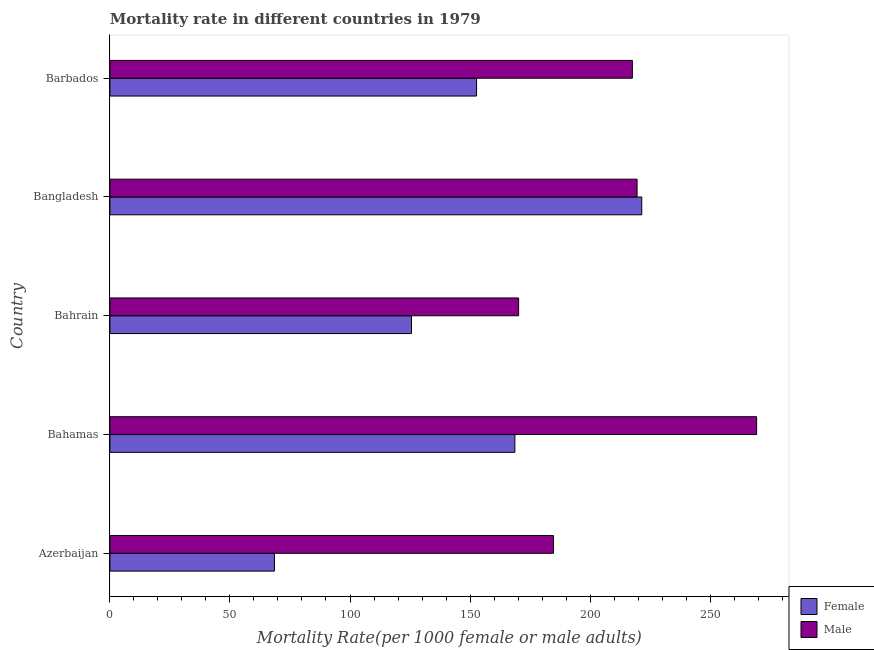How many different coloured bars are there?
Your answer should be very brief. 2. Are the number of bars per tick equal to the number of legend labels?
Offer a terse response. Yes. What is the label of the 5th group of bars from the top?
Your answer should be very brief. Azerbaijan. In how many cases, is the number of bars for a given country not equal to the number of legend labels?
Make the answer very short. 0. What is the female mortality rate in Barbados?
Your response must be concise. 152.72. Across all countries, what is the maximum female mortality rate?
Your answer should be compact. 221.51. Across all countries, what is the minimum female mortality rate?
Make the answer very short. 68.53. In which country was the male mortality rate maximum?
Provide a short and direct response. Bahamas. In which country was the female mortality rate minimum?
Provide a succinct answer. Azerbaijan. What is the total male mortality rate in the graph?
Provide a short and direct response. 1061.5. What is the difference between the female mortality rate in Azerbaijan and that in Bahamas?
Offer a very short reply. -100.13. What is the difference between the female mortality rate in Bangladesh and the male mortality rate in Azerbaijan?
Your response must be concise. 36.78. What is the average male mortality rate per country?
Your answer should be very brief. 212.3. What is the difference between the male mortality rate and female mortality rate in Barbados?
Offer a terse response. 64.89. What is the ratio of the male mortality rate in Bahamas to that in Bahrain?
Offer a terse response. 1.58. Is the male mortality rate in Bangladesh less than that in Barbados?
Your answer should be compact. No. What is the difference between the highest and the second highest female mortality rate?
Give a very brief answer. 52.84. What is the difference between the highest and the lowest male mortality rate?
Keep it short and to the point. 99.13. In how many countries, is the male mortality rate greater than the average male mortality rate taken over all countries?
Your response must be concise. 3. Is the sum of the male mortality rate in Bahamas and Bangladesh greater than the maximum female mortality rate across all countries?
Your answer should be very brief. Yes. How many bars are there?
Your answer should be compact. 10. Are all the bars in the graph horizontal?
Keep it short and to the point. Yes. Does the graph contain grids?
Offer a very short reply. No. How many legend labels are there?
Offer a very short reply. 2. How are the legend labels stacked?
Offer a very short reply. Vertical. What is the title of the graph?
Offer a terse response. Mortality rate in different countries in 1979. Does "Measles" appear as one of the legend labels in the graph?
Offer a terse response. No. What is the label or title of the X-axis?
Your answer should be compact. Mortality Rate(per 1000 female or male adults). What is the Mortality Rate(per 1000 female or male adults) in Female in Azerbaijan?
Your answer should be very brief. 68.53. What is the Mortality Rate(per 1000 female or male adults) of Male in Azerbaijan?
Provide a succinct answer. 184.73. What is the Mortality Rate(per 1000 female or male adults) in Female in Bahamas?
Ensure brevity in your answer.  168.67. What is the Mortality Rate(per 1000 female or male adults) of Male in Bahamas?
Offer a very short reply. 269.36. What is the Mortality Rate(per 1000 female or male adults) in Female in Bahrain?
Provide a short and direct response. 125.61. What is the Mortality Rate(per 1000 female or male adults) in Male in Bahrain?
Make the answer very short. 170.23. What is the Mortality Rate(per 1000 female or male adults) in Female in Bangladesh?
Your response must be concise. 221.51. What is the Mortality Rate(per 1000 female or male adults) of Male in Bangladesh?
Provide a short and direct response. 219.57. What is the Mortality Rate(per 1000 female or male adults) of Female in Barbados?
Offer a terse response. 152.72. What is the Mortality Rate(per 1000 female or male adults) in Male in Barbados?
Provide a short and direct response. 217.61. Across all countries, what is the maximum Mortality Rate(per 1000 female or male adults) of Female?
Ensure brevity in your answer.  221.51. Across all countries, what is the maximum Mortality Rate(per 1000 female or male adults) of Male?
Offer a terse response. 269.36. Across all countries, what is the minimum Mortality Rate(per 1000 female or male adults) of Female?
Offer a terse response. 68.53. Across all countries, what is the minimum Mortality Rate(per 1000 female or male adults) in Male?
Offer a very short reply. 170.23. What is the total Mortality Rate(per 1000 female or male adults) in Female in the graph?
Ensure brevity in your answer.  737.03. What is the total Mortality Rate(per 1000 female or male adults) of Male in the graph?
Provide a succinct answer. 1061.5. What is the difference between the Mortality Rate(per 1000 female or male adults) of Female in Azerbaijan and that in Bahamas?
Keep it short and to the point. -100.13. What is the difference between the Mortality Rate(per 1000 female or male adults) of Male in Azerbaijan and that in Bahamas?
Your response must be concise. -84.63. What is the difference between the Mortality Rate(per 1000 female or male adults) in Female in Azerbaijan and that in Bahrain?
Your response must be concise. -57.07. What is the difference between the Mortality Rate(per 1000 female or male adults) in Male in Azerbaijan and that in Bahrain?
Your answer should be very brief. 14.5. What is the difference between the Mortality Rate(per 1000 female or male adults) in Female in Azerbaijan and that in Bangladesh?
Make the answer very short. -152.98. What is the difference between the Mortality Rate(per 1000 female or male adults) of Male in Azerbaijan and that in Bangladesh?
Offer a very short reply. -34.83. What is the difference between the Mortality Rate(per 1000 female or male adults) of Female in Azerbaijan and that in Barbados?
Provide a succinct answer. -84.18. What is the difference between the Mortality Rate(per 1000 female or male adults) of Male in Azerbaijan and that in Barbados?
Provide a short and direct response. -32.88. What is the difference between the Mortality Rate(per 1000 female or male adults) in Female in Bahamas and that in Bahrain?
Your response must be concise. 43.06. What is the difference between the Mortality Rate(per 1000 female or male adults) in Male in Bahamas and that in Bahrain?
Make the answer very short. 99.13. What is the difference between the Mortality Rate(per 1000 female or male adults) in Female in Bahamas and that in Bangladesh?
Your response must be concise. -52.84. What is the difference between the Mortality Rate(per 1000 female or male adults) of Male in Bahamas and that in Bangladesh?
Ensure brevity in your answer.  49.79. What is the difference between the Mortality Rate(per 1000 female or male adults) in Female in Bahamas and that in Barbados?
Offer a terse response. 15.95. What is the difference between the Mortality Rate(per 1000 female or male adults) of Male in Bahamas and that in Barbados?
Offer a very short reply. 51.75. What is the difference between the Mortality Rate(per 1000 female or male adults) in Female in Bahrain and that in Bangladesh?
Ensure brevity in your answer.  -95.91. What is the difference between the Mortality Rate(per 1000 female or male adults) in Male in Bahrain and that in Bangladesh?
Keep it short and to the point. -49.34. What is the difference between the Mortality Rate(per 1000 female or male adults) in Female in Bahrain and that in Barbados?
Your answer should be compact. -27.11. What is the difference between the Mortality Rate(per 1000 female or male adults) of Male in Bahrain and that in Barbados?
Make the answer very short. -47.38. What is the difference between the Mortality Rate(per 1000 female or male adults) of Female in Bangladesh and that in Barbados?
Your answer should be very brief. 68.8. What is the difference between the Mortality Rate(per 1000 female or male adults) of Male in Bangladesh and that in Barbados?
Provide a short and direct response. 1.96. What is the difference between the Mortality Rate(per 1000 female or male adults) of Female in Azerbaijan and the Mortality Rate(per 1000 female or male adults) of Male in Bahamas?
Your answer should be very brief. -200.83. What is the difference between the Mortality Rate(per 1000 female or male adults) of Female in Azerbaijan and the Mortality Rate(per 1000 female or male adults) of Male in Bahrain?
Keep it short and to the point. -101.7. What is the difference between the Mortality Rate(per 1000 female or male adults) of Female in Azerbaijan and the Mortality Rate(per 1000 female or male adults) of Male in Bangladesh?
Offer a terse response. -151.03. What is the difference between the Mortality Rate(per 1000 female or male adults) in Female in Azerbaijan and the Mortality Rate(per 1000 female or male adults) in Male in Barbados?
Your answer should be compact. -149.07. What is the difference between the Mortality Rate(per 1000 female or male adults) in Female in Bahamas and the Mortality Rate(per 1000 female or male adults) in Male in Bahrain?
Your answer should be very brief. -1.56. What is the difference between the Mortality Rate(per 1000 female or male adults) in Female in Bahamas and the Mortality Rate(per 1000 female or male adults) in Male in Bangladesh?
Offer a terse response. -50.9. What is the difference between the Mortality Rate(per 1000 female or male adults) of Female in Bahamas and the Mortality Rate(per 1000 female or male adults) of Male in Barbados?
Your response must be concise. -48.94. What is the difference between the Mortality Rate(per 1000 female or male adults) in Female in Bahrain and the Mortality Rate(per 1000 female or male adults) in Male in Bangladesh?
Your response must be concise. -93.96. What is the difference between the Mortality Rate(per 1000 female or male adults) in Female in Bahrain and the Mortality Rate(per 1000 female or male adults) in Male in Barbados?
Offer a terse response. -92. What is the difference between the Mortality Rate(per 1000 female or male adults) in Female in Bangladesh and the Mortality Rate(per 1000 female or male adults) in Male in Barbados?
Keep it short and to the point. 3.9. What is the average Mortality Rate(per 1000 female or male adults) in Female per country?
Offer a very short reply. 147.41. What is the average Mortality Rate(per 1000 female or male adults) of Male per country?
Your response must be concise. 212.3. What is the difference between the Mortality Rate(per 1000 female or male adults) of Female and Mortality Rate(per 1000 female or male adults) of Male in Azerbaijan?
Ensure brevity in your answer.  -116.2. What is the difference between the Mortality Rate(per 1000 female or male adults) of Female and Mortality Rate(per 1000 female or male adults) of Male in Bahamas?
Your response must be concise. -100.69. What is the difference between the Mortality Rate(per 1000 female or male adults) in Female and Mortality Rate(per 1000 female or male adults) in Male in Bahrain?
Ensure brevity in your answer.  -44.62. What is the difference between the Mortality Rate(per 1000 female or male adults) of Female and Mortality Rate(per 1000 female or male adults) of Male in Bangladesh?
Make the answer very short. 1.95. What is the difference between the Mortality Rate(per 1000 female or male adults) of Female and Mortality Rate(per 1000 female or male adults) of Male in Barbados?
Keep it short and to the point. -64.89. What is the ratio of the Mortality Rate(per 1000 female or male adults) in Female in Azerbaijan to that in Bahamas?
Offer a terse response. 0.41. What is the ratio of the Mortality Rate(per 1000 female or male adults) of Male in Azerbaijan to that in Bahamas?
Your answer should be compact. 0.69. What is the ratio of the Mortality Rate(per 1000 female or male adults) of Female in Azerbaijan to that in Bahrain?
Offer a very short reply. 0.55. What is the ratio of the Mortality Rate(per 1000 female or male adults) in Male in Azerbaijan to that in Bahrain?
Your answer should be compact. 1.09. What is the ratio of the Mortality Rate(per 1000 female or male adults) of Female in Azerbaijan to that in Bangladesh?
Offer a terse response. 0.31. What is the ratio of the Mortality Rate(per 1000 female or male adults) in Male in Azerbaijan to that in Bangladesh?
Your answer should be compact. 0.84. What is the ratio of the Mortality Rate(per 1000 female or male adults) in Female in Azerbaijan to that in Barbados?
Offer a very short reply. 0.45. What is the ratio of the Mortality Rate(per 1000 female or male adults) in Male in Azerbaijan to that in Barbados?
Your answer should be compact. 0.85. What is the ratio of the Mortality Rate(per 1000 female or male adults) in Female in Bahamas to that in Bahrain?
Ensure brevity in your answer.  1.34. What is the ratio of the Mortality Rate(per 1000 female or male adults) of Male in Bahamas to that in Bahrain?
Your response must be concise. 1.58. What is the ratio of the Mortality Rate(per 1000 female or male adults) of Female in Bahamas to that in Bangladesh?
Make the answer very short. 0.76. What is the ratio of the Mortality Rate(per 1000 female or male adults) of Male in Bahamas to that in Bangladesh?
Your answer should be very brief. 1.23. What is the ratio of the Mortality Rate(per 1000 female or male adults) in Female in Bahamas to that in Barbados?
Provide a short and direct response. 1.1. What is the ratio of the Mortality Rate(per 1000 female or male adults) of Male in Bahamas to that in Barbados?
Provide a succinct answer. 1.24. What is the ratio of the Mortality Rate(per 1000 female or male adults) in Female in Bahrain to that in Bangladesh?
Make the answer very short. 0.57. What is the ratio of the Mortality Rate(per 1000 female or male adults) in Male in Bahrain to that in Bangladesh?
Your response must be concise. 0.78. What is the ratio of the Mortality Rate(per 1000 female or male adults) of Female in Bahrain to that in Barbados?
Keep it short and to the point. 0.82. What is the ratio of the Mortality Rate(per 1000 female or male adults) of Male in Bahrain to that in Barbados?
Offer a terse response. 0.78. What is the ratio of the Mortality Rate(per 1000 female or male adults) of Female in Bangladesh to that in Barbados?
Provide a succinct answer. 1.45. What is the ratio of the Mortality Rate(per 1000 female or male adults) of Male in Bangladesh to that in Barbados?
Keep it short and to the point. 1.01. What is the difference between the highest and the second highest Mortality Rate(per 1000 female or male adults) of Female?
Make the answer very short. 52.84. What is the difference between the highest and the second highest Mortality Rate(per 1000 female or male adults) of Male?
Your answer should be compact. 49.79. What is the difference between the highest and the lowest Mortality Rate(per 1000 female or male adults) of Female?
Your answer should be compact. 152.98. What is the difference between the highest and the lowest Mortality Rate(per 1000 female or male adults) of Male?
Offer a terse response. 99.13. 